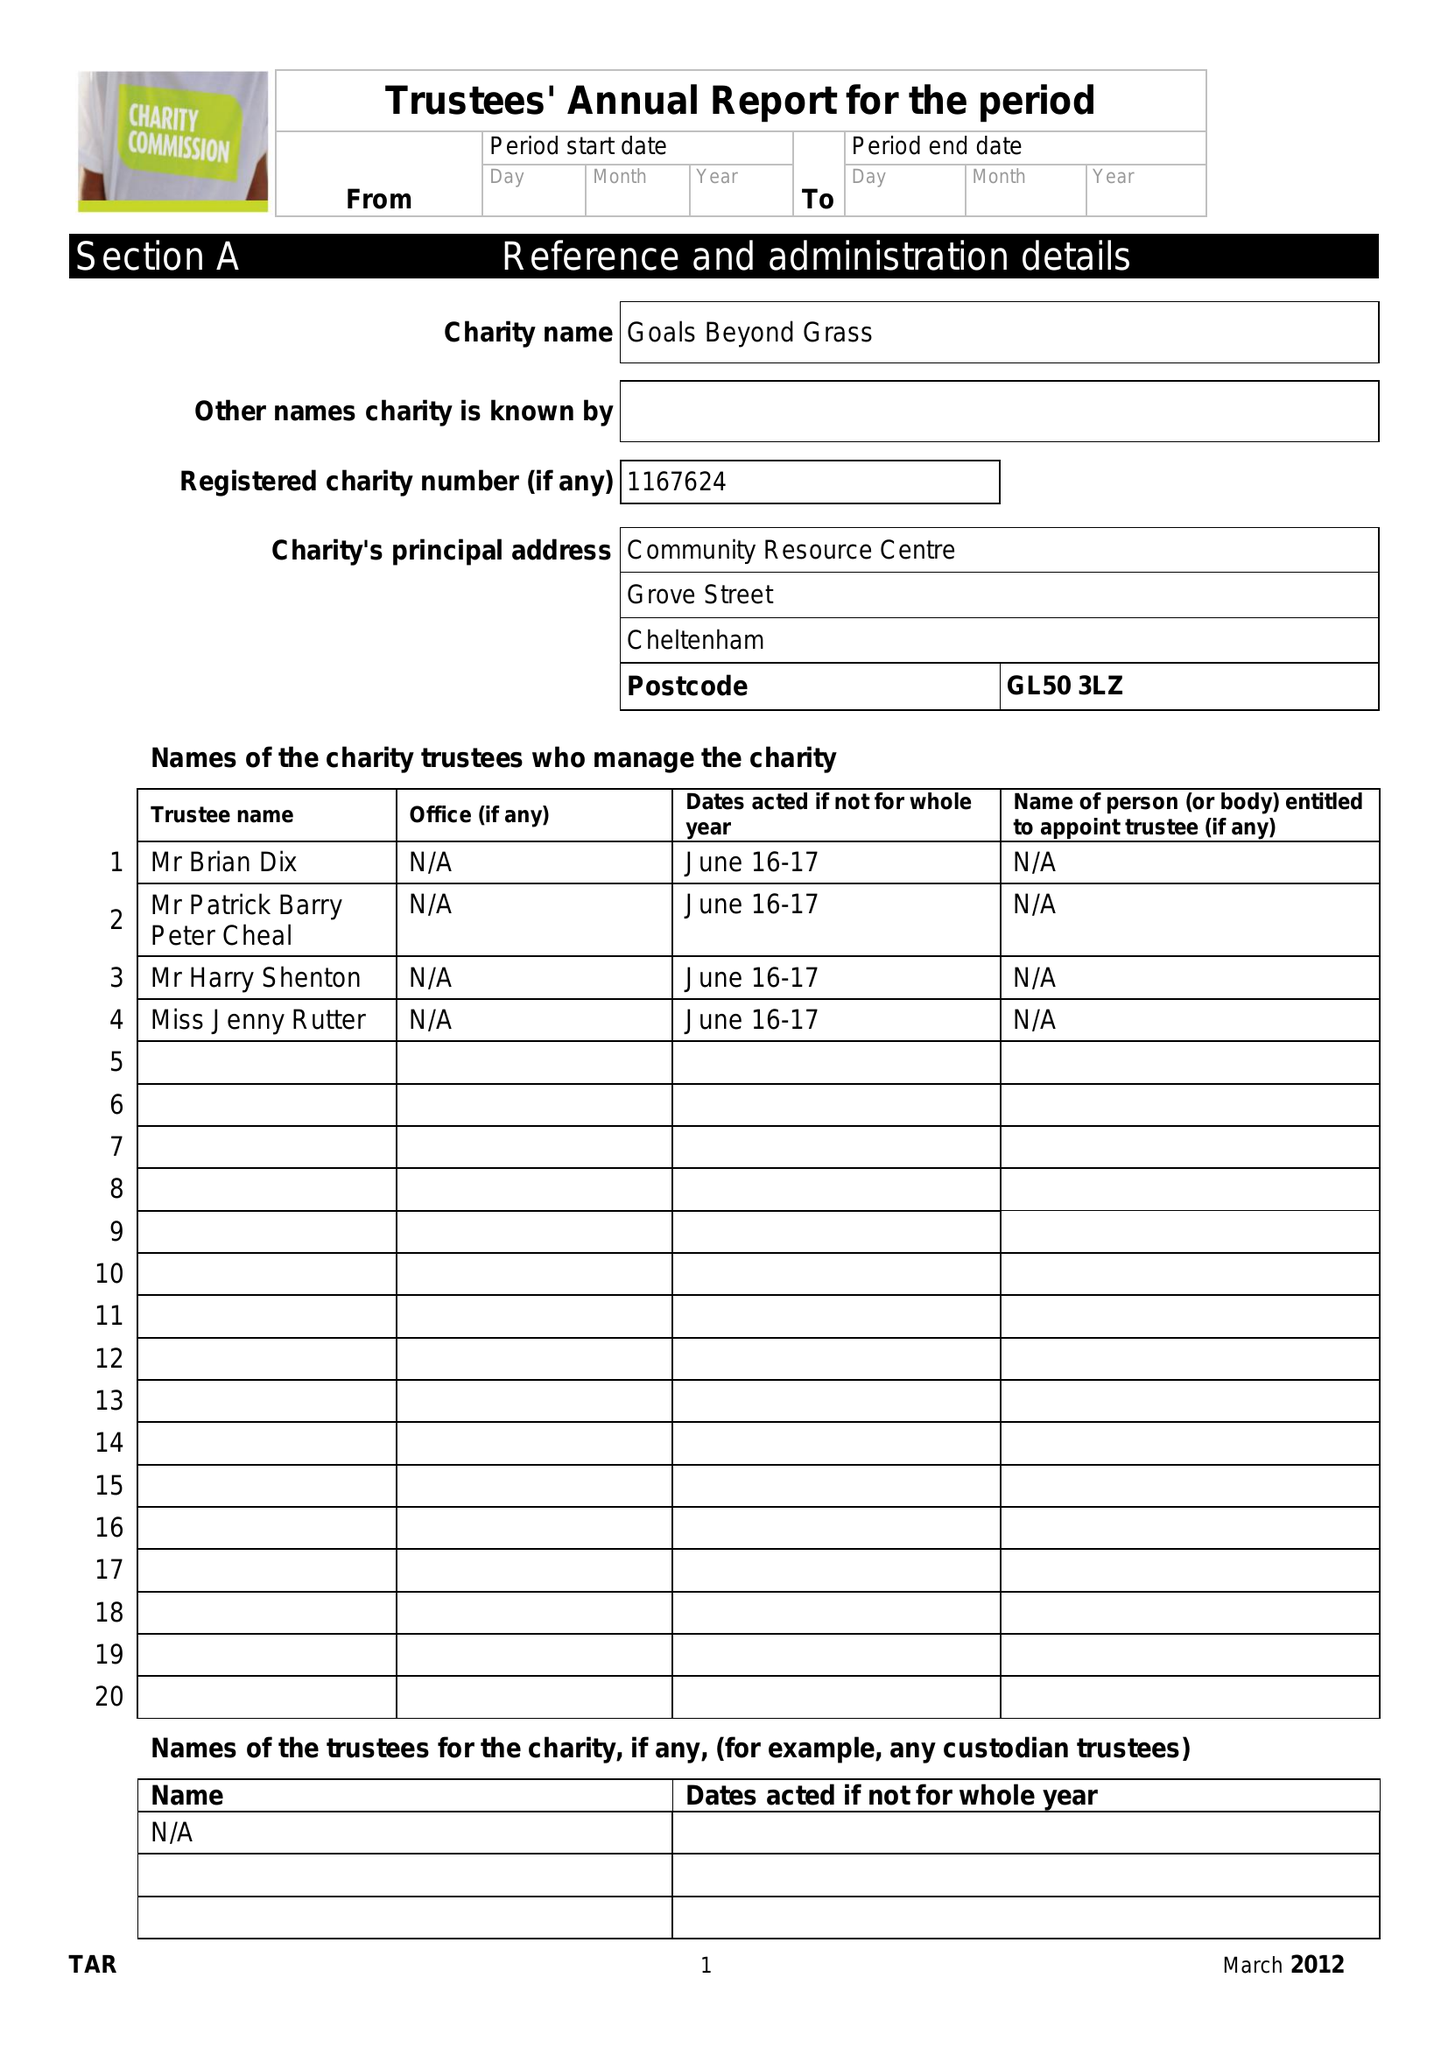What is the value for the address__postcode?
Answer the question using a single word or phrase. GL1 3NU 